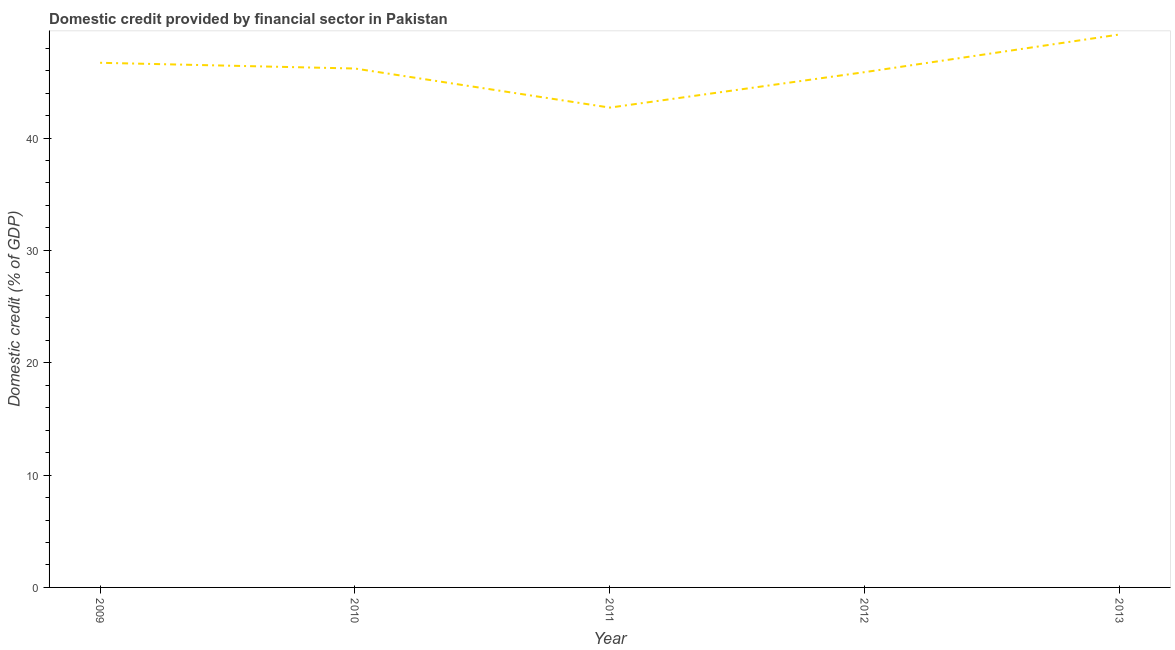What is the domestic credit provided by financial sector in 2009?
Ensure brevity in your answer.  46.7. Across all years, what is the maximum domestic credit provided by financial sector?
Your answer should be compact. 49.22. Across all years, what is the minimum domestic credit provided by financial sector?
Provide a succinct answer. 42.71. In which year was the domestic credit provided by financial sector maximum?
Offer a very short reply. 2013. What is the sum of the domestic credit provided by financial sector?
Your response must be concise. 230.67. What is the difference between the domestic credit provided by financial sector in 2009 and 2012?
Keep it short and to the point. 0.83. What is the average domestic credit provided by financial sector per year?
Offer a very short reply. 46.13. What is the median domestic credit provided by financial sector?
Your answer should be compact. 46.19. In how many years, is the domestic credit provided by financial sector greater than 32 %?
Offer a very short reply. 5. What is the ratio of the domestic credit provided by financial sector in 2010 to that in 2011?
Your answer should be compact. 1.08. Is the domestic credit provided by financial sector in 2010 less than that in 2012?
Offer a terse response. No. Is the difference between the domestic credit provided by financial sector in 2012 and 2013 greater than the difference between any two years?
Your answer should be compact. No. What is the difference between the highest and the second highest domestic credit provided by financial sector?
Make the answer very short. 2.52. Is the sum of the domestic credit provided by financial sector in 2009 and 2010 greater than the maximum domestic credit provided by financial sector across all years?
Your answer should be compact. Yes. What is the difference between the highest and the lowest domestic credit provided by financial sector?
Ensure brevity in your answer.  6.51. In how many years, is the domestic credit provided by financial sector greater than the average domestic credit provided by financial sector taken over all years?
Your answer should be compact. 3. How many lines are there?
Your answer should be very brief. 1. Are the values on the major ticks of Y-axis written in scientific E-notation?
Offer a very short reply. No. Does the graph contain grids?
Provide a short and direct response. No. What is the title of the graph?
Your answer should be compact. Domestic credit provided by financial sector in Pakistan. What is the label or title of the X-axis?
Provide a short and direct response. Year. What is the label or title of the Y-axis?
Your response must be concise. Domestic credit (% of GDP). What is the Domestic credit (% of GDP) of 2009?
Make the answer very short. 46.7. What is the Domestic credit (% of GDP) of 2010?
Offer a terse response. 46.19. What is the Domestic credit (% of GDP) of 2011?
Ensure brevity in your answer.  42.71. What is the Domestic credit (% of GDP) in 2012?
Offer a very short reply. 45.86. What is the Domestic credit (% of GDP) of 2013?
Keep it short and to the point. 49.22. What is the difference between the Domestic credit (% of GDP) in 2009 and 2010?
Provide a succinct answer. 0.51. What is the difference between the Domestic credit (% of GDP) in 2009 and 2011?
Offer a terse response. 3.99. What is the difference between the Domestic credit (% of GDP) in 2009 and 2012?
Your answer should be very brief. 0.83. What is the difference between the Domestic credit (% of GDP) in 2009 and 2013?
Give a very brief answer. -2.52. What is the difference between the Domestic credit (% of GDP) in 2010 and 2011?
Keep it short and to the point. 3.48. What is the difference between the Domestic credit (% of GDP) in 2010 and 2012?
Keep it short and to the point. 0.32. What is the difference between the Domestic credit (% of GDP) in 2010 and 2013?
Offer a terse response. -3.03. What is the difference between the Domestic credit (% of GDP) in 2011 and 2012?
Your answer should be compact. -3.16. What is the difference between the Domestic credit (% of GDP) in 2011 and 2013?
Your answer should be very brief. -6.51. What is the difference between the Domestic credit (% of GDP) in 2012 and 2013?
Ensure brevity in your answer.  -3.35. What is the ratio of the Domestic credit (% of GDP) in 2009 to that in 2011?
Provide a succinct answer. 1.09. What is the ratio of the Domestic credit (% of GDP) in 2009 to that in 2012?
Offer a very short reply. 1.02. What is the ratio of the Domestic credit (% of GDP) in 2009 to that in 2013?
Your response must be concise. 0.95. What is the ratio of the Domestic credit (% of GDP) in 2010 to that in 2011?
Your answer should be compact. 1.08. What is the ratio of the Domestic credit (% of GDP) in 2010 to that in 2012?
Keep it short and to the point. 1.01. What is the ratio of the Domestic credit (% of GDP) in 2010 to that in 2013?
Provide a succinct answer. 0.94. What is the ratio of the Domestic credit (% of GDP) in 2011 to that in 2013?
Give a very brief answer. 0.87. What is the ratio of the Domestic credit (% of GDP) in 2012 to that in 2013?
Provide a succinct answer. 0.93. 